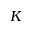<formula> <loc_0><loc_0><loc_500><loc_500>K</formula> 